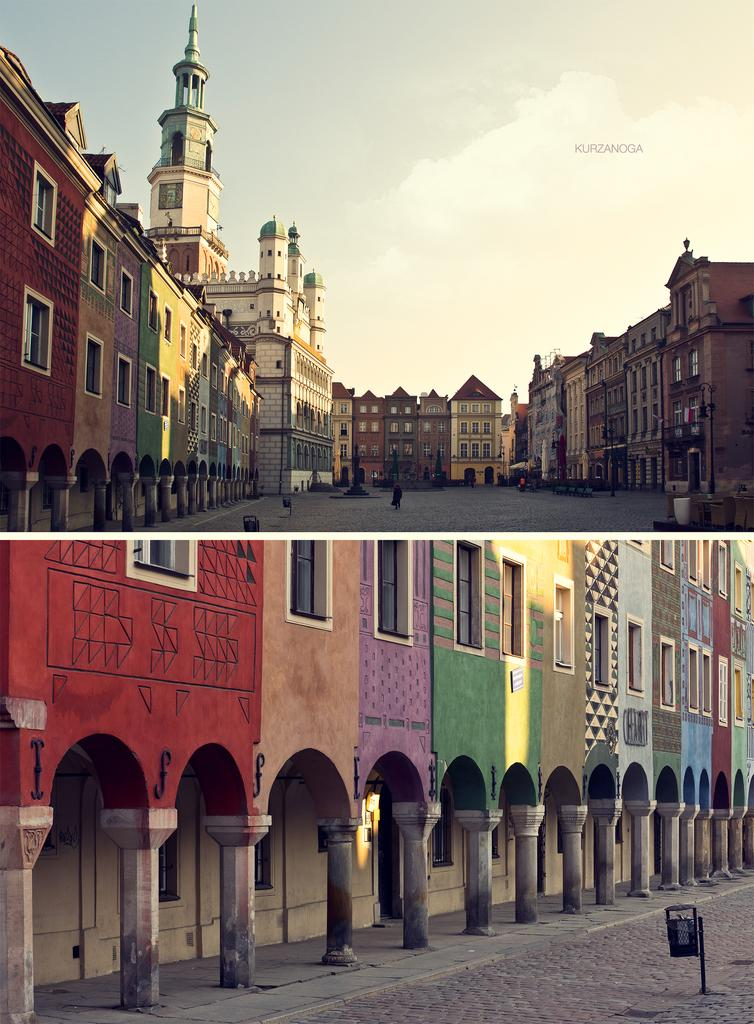What type of artwork is the image? The image is a collage. What type of structures can be seen in the image? There are buildings in the image. What is visible beneath the buildings? There is ground visible in the image. What is present on the ground? There are objects on the ground. What can be seen above the buildings and objects? The sky is visible in the image. Is there a person in the image? Yes, there is a person in the first part of the image. How many cent coins are scattered on the ground in the image? There is no mention of cent coins in the image, so we cannot determine their presence or quantity. 